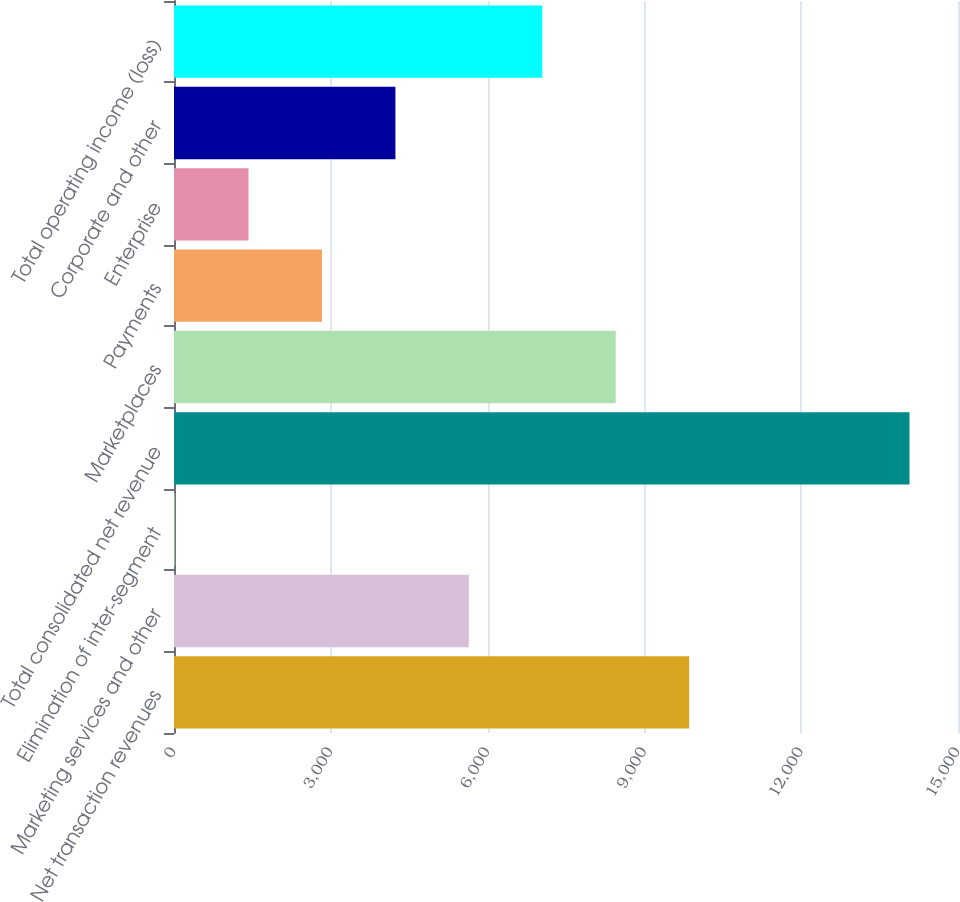Convert chart to OTSL. <chart><loc_0><loc_0><loc_500><loc_500><bar_chart><fcel>Net transaction revenues<fcel>Marketing services and other<fcel>Elimination of inter-segment<fcel>Total consolidated net revenue<fcel>Marketplaces<fcel>Payments<fcel>Enterprise<fcel>Corporate and other<fcel>Total operating income (loss)<nl><fcel>9856.7<fcel>5641.4<fcel>21<fcel>14072<fcel>8451.6<fcel>2831.2<fcel>1426.1<fcel>4236.3<fcel>7046.5<nl></chart> 